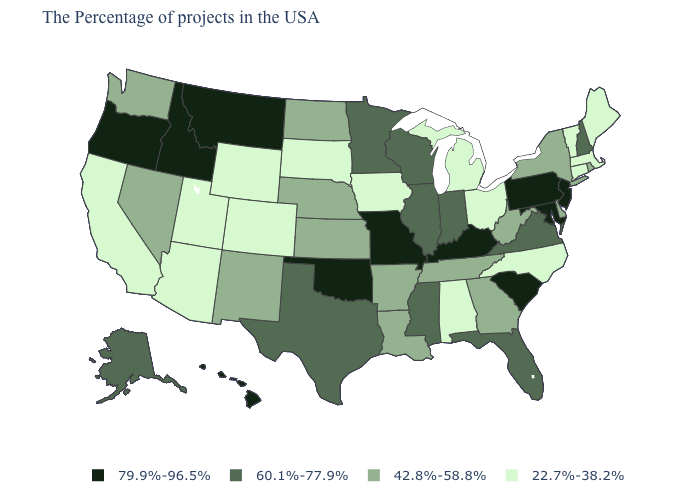Among the states that border Vermont , which have the lowest value?
Be succinct. Massachusetts. What is the lowest value in states that border Idaho?
Keep it brief. 22.7%-38.2%. Does the map have missing data?
Give a very brief answer. No. Among the states that border Missouri , which have the highest value?
Keep it brief. Kentucky, Oklahoma. What is the highest value in the USA?
Answer briefly. 79.9%-96.5%. Does the first symbol in the legend represent the smallest category?
Keep it brief. No. Among the states that border North Carolina , which have the highest value?
Quick response, please. South Carolina. Name the states that have a value in the range 79.9%-96.5%?
Answer briefly. New Jersey, Maryland, Pennsylvania, South Carolina, Kentucky, Missouri, Oklahoma, Montana, Idaho, Oregon, Hawaii. What is the highest value in the USA?
Answer briefly. 79.9%-96.5%. Is the legend a continuous bar?
Be succinct. No. What is the value of Florida?
Short answer required. 60.1%-77.9%. Does Kentucky have the highest value in the South?
Give a very brief answer. Yes. What is the value of Nevada?
Be succinct. 42.8%-58.8%. What is the value of Delaware?
Give a very brief answer. 42.8%-58.8%. Name the states that have a value in the range 79.9%-96.5%?
Keep it brief. New Jersey, Maryland, Pennsylvania, South Carolina, Kentucky, Missouri, Oklahoma, Montana, Idaho, Oregon, Hawaii. 